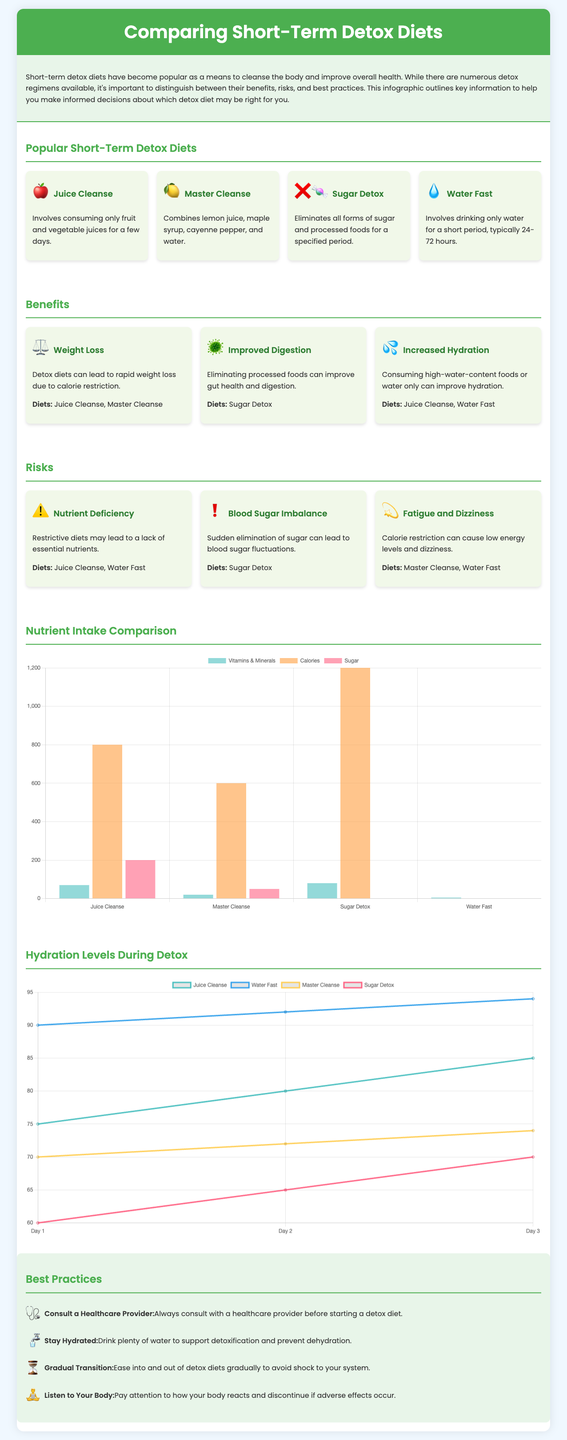What are the four popular detox diets listed? The document lists Juice Cleanse, Master Cleanse, Sugar Detox, and Water Fast as the popular detox diets.
Answer: Juice Cleanse, Master Cleanse, Sugar Detox, Water Fast Which detox diet is associated with improved digestion? The document states that the Sugar Detox can improve digestion by eliminating processed foods.
Answer: Sugar Detox What is a potential risk of a Juice Cleanse? The document indicates that a Juice Cleanse may lead to nutrient deficiency due to its restrictive nature.
Answer: Nutrient Deficiency How many days does a Water Fast typically last? The document mentions that a Water Fast usually lasts between 24 to 72 hours.
Answer: 24-72 hours What percentage of hydration does the Juice Cleanse reach by Day 3? The hydration chart shows that the Juice Cleanse reaches 85% hydration by Day 3.
Answer: 85% What should individuals do before starting a detox diet according to best practices? The document emphasizes the importance of consulting a healthcare provider before starting a detox diet.
Answer: Consult a Healthcare Provider Which detox diet results in the highest calorie intake? The Sugar Detox allows for the highest calorie intake as per the nutrient intake comparison in the document.
Answer: Sugar Detox What is the hydration level on Day 2 of a Water Fast? According to the hydration chart, the Water Fast hydration level is at 92% on Day 2.
Answer: 92% 